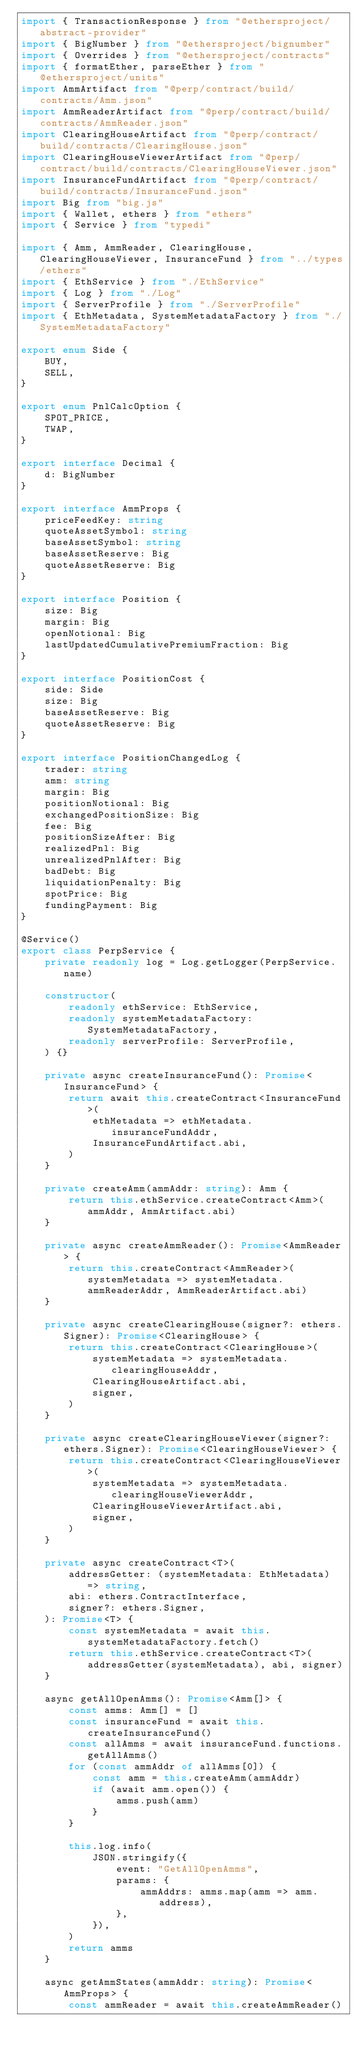<code> <loc_0><loc_0><loc_500><loc_500><_TypeScript_>import { TransactionResponse } from "@ethersproject/abstract-provider"
import { BigNumber } from "@ethersproject/bignumber"
import { Overrides } from "@ethersproject/contracts"
import { formatEther, parseEther } from "@ethersproject/units"
import AmmArtifact from "@perp/contract/build/contracts/Amm.json"
import AmmReaderArtifact from "@perp/contract/build/contracts/AmmReader.json"
import ClearingHouseArtifact from "@perp/contract/build/contracts/ClearingHouse.json"
import ClearingHouseViewerArtifact from "@perp/contract/build/contracts/ClearingHouseViewer.json"
import InsuranceFundArtifact from "@perp/contract/build/contracts/InsuranceFund.json"
import Big from "big.js"
import { Wallet, ethers } from "ethers"
import { Service } from "typedi"

import { Amm, AmmReader, ClearingHouse, ClearingHouseViewer, InsuranceFund } from "../types/ethers"
import { EthService } from "./EthService"
import { Log } from "./Log"
import { ServerProfile } from "./ServerProfile"
import { EthMetadata, SystemMetadataFactory } from "./SystemMetadataFactory"

export enum Side {
    BUY,
    SELL,
}

export enum PnlCalcOption {
    SPOT_PRICE,
    TWAP,
}

export interface Decimal {
    d: BigNumber
}

export interface AmmProps {
    priceFeedKey: string
    quoteAssetSymbol: string
    baseAssetSymbol: string
    baseAssetReserve: Big
    quoteAssetReserve: Big
}

export interface Position {
    size: Big
    margin: Big
    openNotional: Big
    lastUpdatedCumulativePremiumFraction: Big
}

export interface PositionCost {
    side: Side
    size: Big
    baseAssetReserve: Big
    quoteAssetReserve: Big
}

export interface PositionChangedLog {
    trader: string
    amm: string
    margin: Big
    positionNotional: Big
    exchangedPositionSize: Big
    fee: Big
    positionSizeAfter: Big
    realizedPnl: Big
    unrealizedPnlAfter: Big
    badDebt: Big
    liquidationPenalty: Big
    spotPrice: Big
    fundingPayment: Big
}

@Service()
export class PerpService {
    private readonly log = Log.getLogger(PerpService.name)

    constructor(
        readonly ethService: EthService,
        readonly systemMetadataFactory: SystemMetadataFactory,
        readonly serverProfile: ServerProfile,
    ) {}

    private async createInsuranceFund(): Promise<InsuranceFund> {
        return await this.createContract<InsuranceFund>(
            ethMetadata => ethMetadata.insuranceFundAddr,
            InsuranceFundArtifact.abi,
        )
    }

    private createAmm(ammAddr: string): Amm {
        return this.ethService.createContract<Amm>(ammAddr, AmmArtifact.abi)
    }

    private async createAmmReader(): Promise<AmmReader> {
        return this.createContract<AmmReader>(systemMetadata => systemMetadata.ammReaderAddr, AmmReaderArtifact.abi)
    }

    private async createClearingHouse(signer?: ethers.Signer): Promise<ClearingHouse> {
        return this.createContract<ClearingHouse>(
            systemMetadata => systemMetadata.clearingHouseAddr,
            ClearingHouseArtifact.abi,
            signer,
        )
    }

    private async createClearingHouseViewer(signer?: ethers.Signer): Promise<ClearingHouseViewer> {
        return this.createContract<ClearingHouseViewer>(
            systemMetadata => systemMetadata.clearingHouseViewerAddr,
            ClearingHouseViewerArtifact.abi,
            signer,
        )
    }

    private async createContract<T>(
        addressGetter: (systemMetadata: EthMetadata) => string,
        abi: ethers.ContractInterface,
        signer?: ethers.Signer,
    ): Promise<T> {
        const systemMetadata = await this.systemMetadataFactory.fetch()
        return this.ethService.createContract<T>(addressGetter(systemMetadata), abi, signer)
    }

    async getAllOpenAmms(): Promise<Amm[]> {
        const amms: Amm[] = []
        const insuranceFund = await this.createInsuranceFund()
        const allAmms = await insuranceFund.functions.getAllAmms()
        for (const ammAddr of allAmms[0]) {
            const amm = this.createAmm(ammAddr)
            if (await amm.open()) {
                amms.push(amm)
            }
        }

        this.log.info(
            JSON.stringify({
                event: "GetAllOpenAmms",
                params: {
                    ammAddrs: amms.map(amm => amm.address),
                },
            }),
        )
        return amms
    }

    async getAmmStates(ammAddr: string): Promise<AmmProps> {
        const ammReader = await this.createAmmReader()</code> 